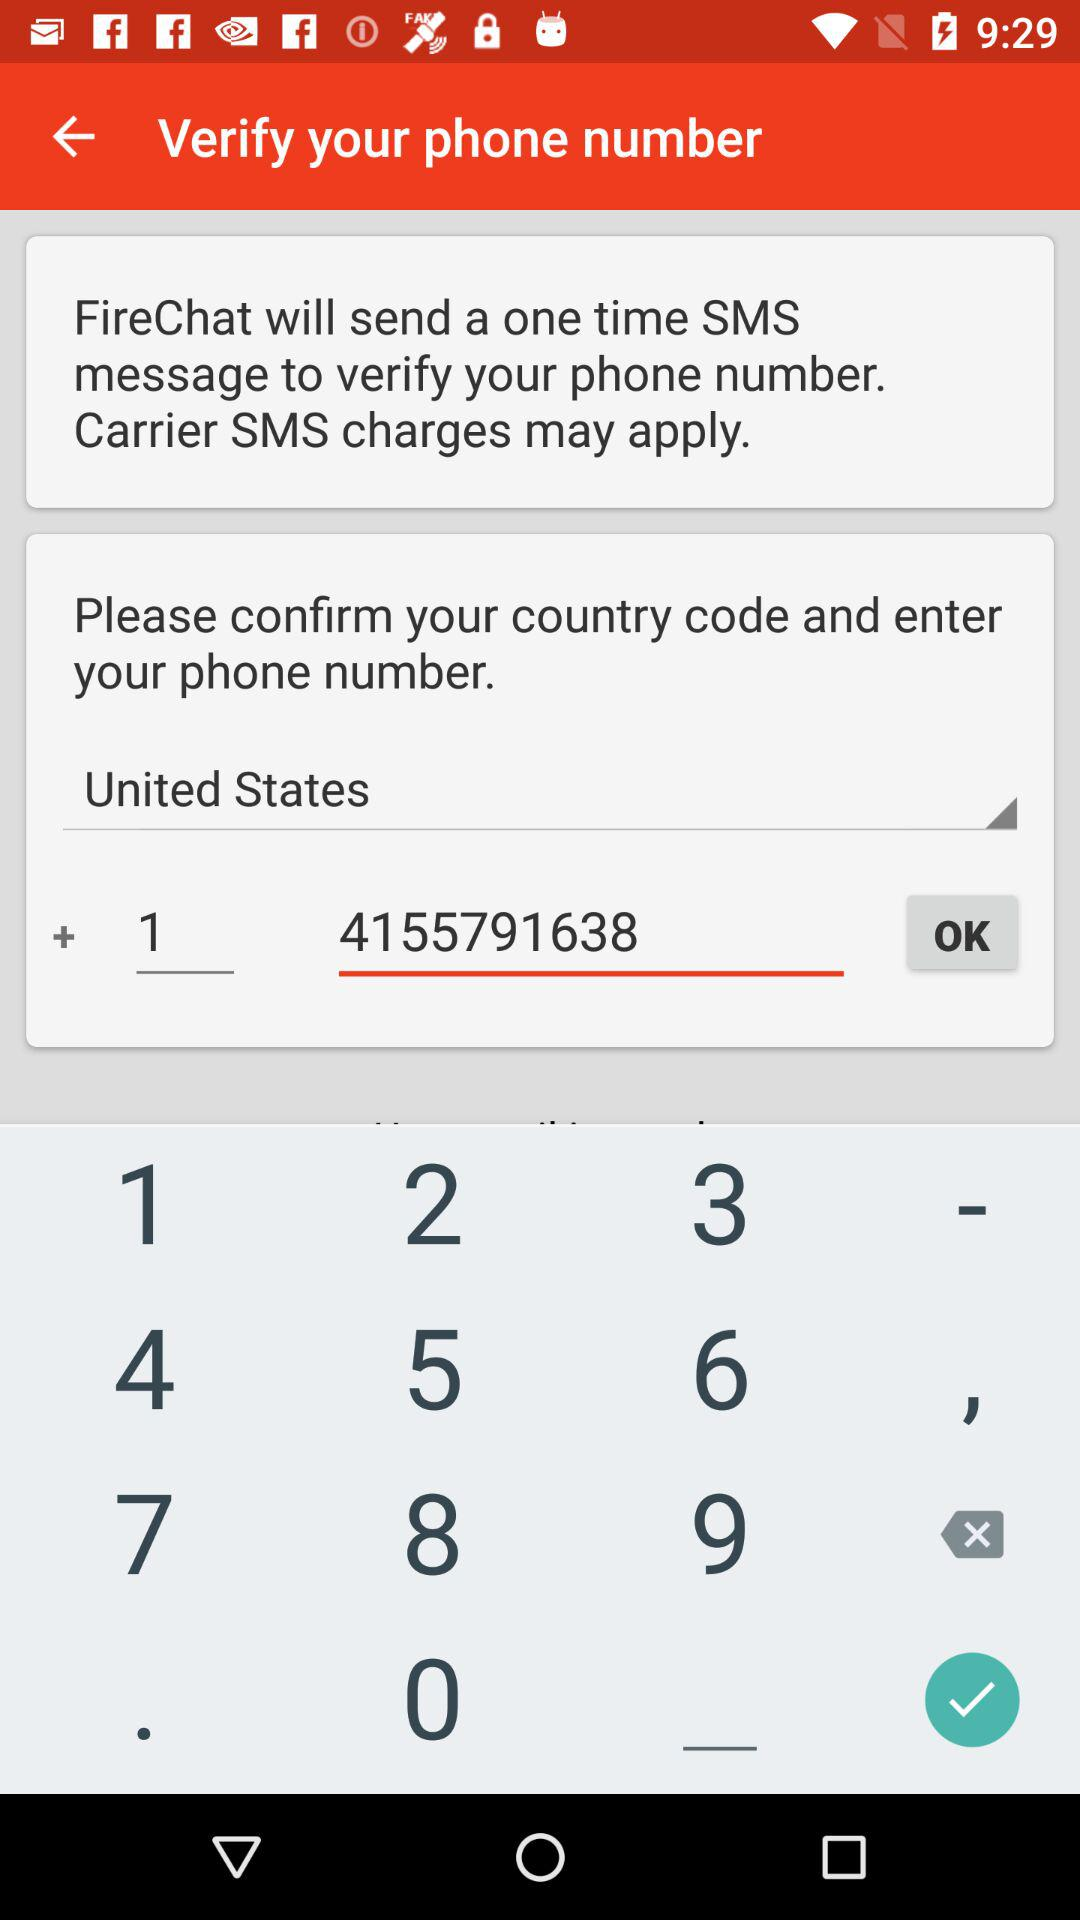What is the country code? The country code is +1. 